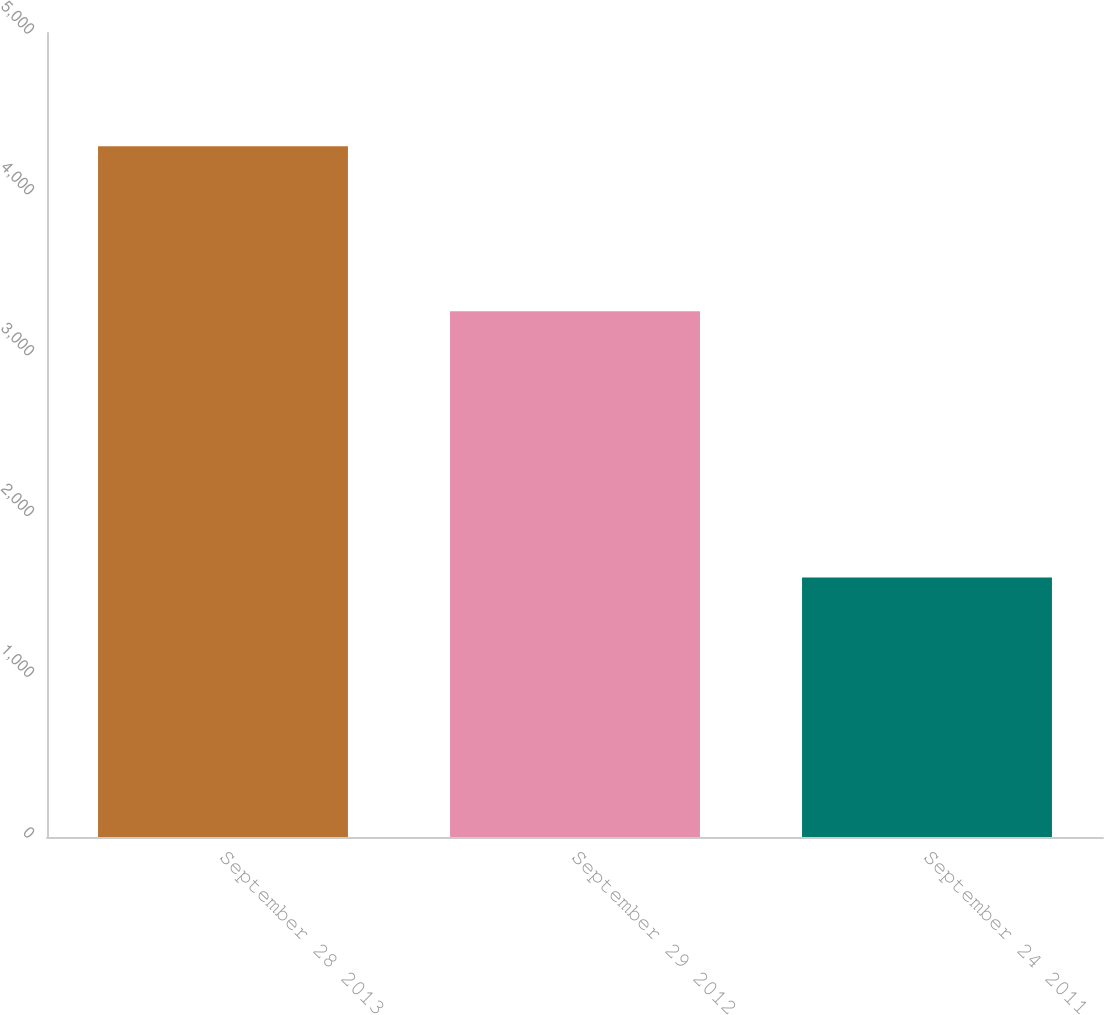<chart> <loc_0><loc_0><loc_500><loc_500><bar_chart><fcel>September 28 2013<fcel>September 29 2012<fcel>September 24 2011<nl><fcel>4296<fcel>3270<fcel>1614<nl></chart> 